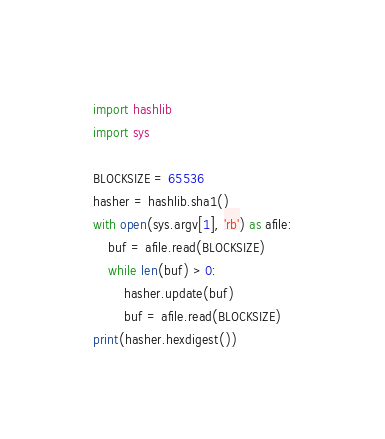<code> <loc_0><loc_0><loc_500><loc_500><_Python_>import hashlib
import sys

BLOCKSIZE = 65536
hasher = hashlib.sha1()
with open(sys.argv[1], 'rb') as afile:
    buf = afile.read(BLOCKSIZE)
    while len(buf) > 0:
        hasher.update(buf)
        buf = afile.read(BLOCKSIZE)
print(hasher.hexdigest())
</code> 